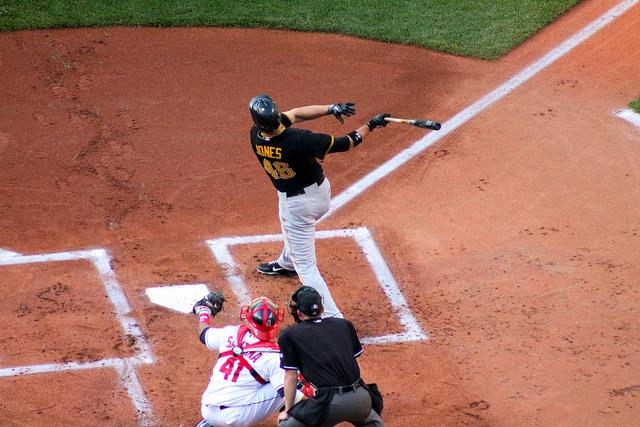What will the standing player do next? run 